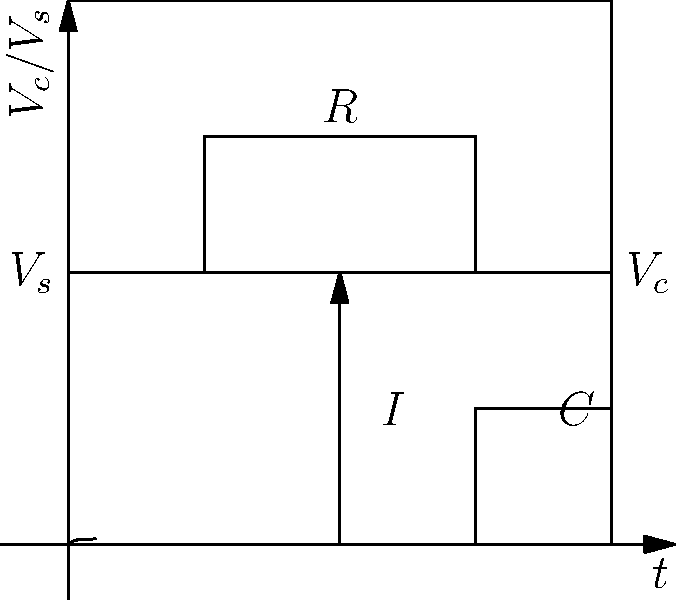In the RC circuit shown, a step voltage $V_s$ is applied at $t=0$. The capacitor voltage $V_c$ rises as shown in the graph. If you were bidding on components for this circuit in an online auction, which parameter would you prioritize to achieve a faster rise time: increasing R or increasing C? To analyze this situation, let's consider the following steps:

1) The time constant $\tau$ of an RC circuit is given by $\tau = RC$.

2) The capacitor voltage in an RC circuit charging from a step input is given by:

   $V_c(t) = V_s(1 - e^{-t/\tau})$

3) The rise time is typically defined as the time it takes for the output to go from 10% to 90% of its final value. This is approximately $2.2\tau$.

4) To achieve a faster rise time, we need to decrease $\tau$.

5) Since $\tau = RC$, we can decrease $\tau$ by either:
   - Decreasing R
   - Decreasing C

6) Therefore, if we were bidding on components, we would want to prioritize decreasing the value of either R or C.

7) Between R and C, it's generally easier and more common to adjust R in circuit design.

8) Also, in many applications, the capacitor value is determined by other circuit requirements, making R the more flexible component to adjust.

Therefore, in an online auction scenario, you would prioritize bidding on resistors with lower resistance values to achieve a faster rise time.
Answer: Decreasing R 